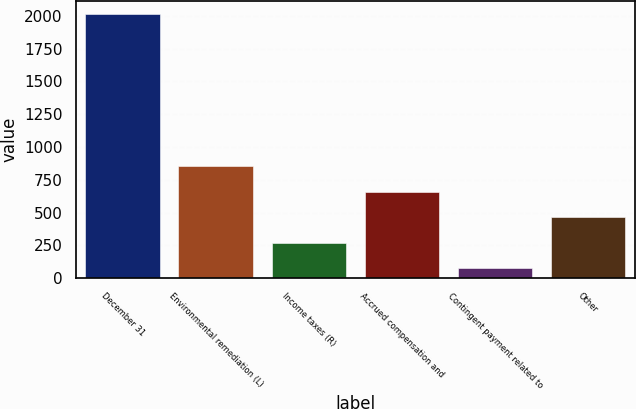Convert chart. <chart><loc_0><loc_0><loc_500><loc_500><bar_chart><fcel>December 31<fcel>Environmental remediation (L)<fcel>Income taxes (R)<fcel>Accrued compensation and<fcel>Contingent payment related to<fcel>Other<nl><fcel>2016<fcel>853.2<fcel>271.8<fcel>659.4<fcel>78<fcel>465.6<nl></chart> 